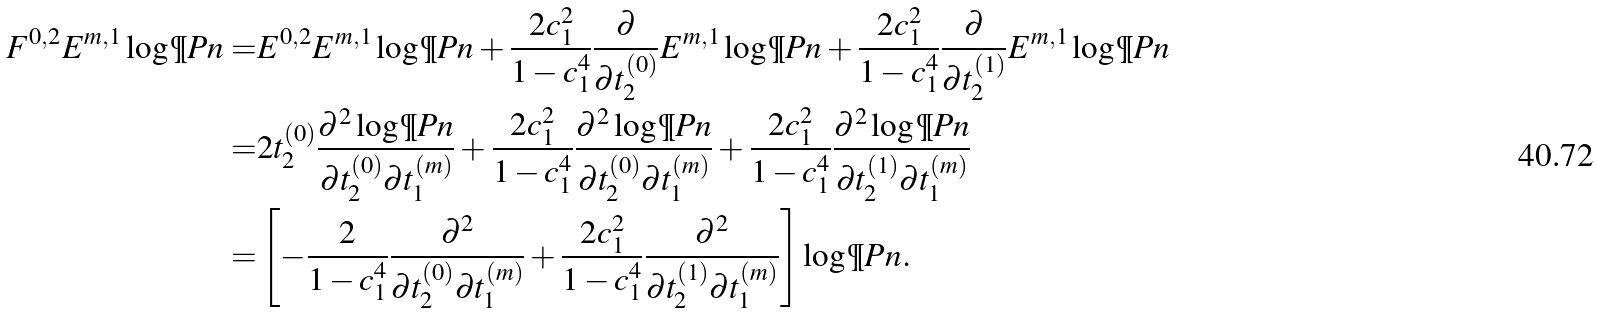Convert formula to latex. <formula><loc_0><loc_0><loc_500><loc_500>F ^ { 0 , 2 } E ^ { m , 1 } \log \P P n = & E ^ { 0 , 2 } E ^ { m , 1 } \log \P P n + \frac { 2 c ^ { 2 } _ { 1 } } { 1 - c ^ { 4 } _ { 1 } } \frac { \partial } { \partial t ^ { ( 0 ) } _ { 2 } } E ^ { m , 1 } \log \P P n + \frac { 2 c ^ { 2 } _ { 1 } } { 1 - c ^ { 4 } _ { 1 } } \frac { \partial } { \partial t ^ { ( 1 ) } _ { 2 } } E ^ { m , 1 } \log \P P n \\ = & 2 t ^ { ( 0 ) } _ { 2 } \frac { \partial ^ { 2 } \log \P P n } { \partial t ^ { ( 0 ) } _ { 2 } \partial t ^ { ( m ) } _ { 1 } } + \frac { 2 c ^ { 2 } _ { 1 } } { 1 - c ^ { 4 } _ { 1 } } \frac { \partial ^ { 2 } \log \P P n } { \partial t ^ { ( 0 ) } _ { 2 } \partial t ^ { ( m ) } _ { 1 } } + \frac { 2 c ^ { 2 } _ { 1 } } { 1 - c ^ { 4 } _ { 1 } } \frac { \partial ^ { 2 } \log \P P n } { \partial t ^ { ( 1 ) } _ { 2 } \partial t ^ { ( m ) } _ { 1 } } \\ = & \left [ - \frac { 2 } { 1 - c ^ { 4 } _ { 1 } } \frac { \partial ^ { 2 } } { \partial t ^ { ( 0 ) } _ { 2 } \partial t ^ { ( m ) } _ { 1 } } + \frac { 2 c ^ { 2 } _ { 1 } } { 1 - c ^ { 4 } _ { 1 } } \frac { \partial ^ { 2 } } { \partial t ^ { ( 1 ) } _ { 2 } \partial t ^ { ( m ) } _ { 1 } } \right ] \log \P P n .</formula> 